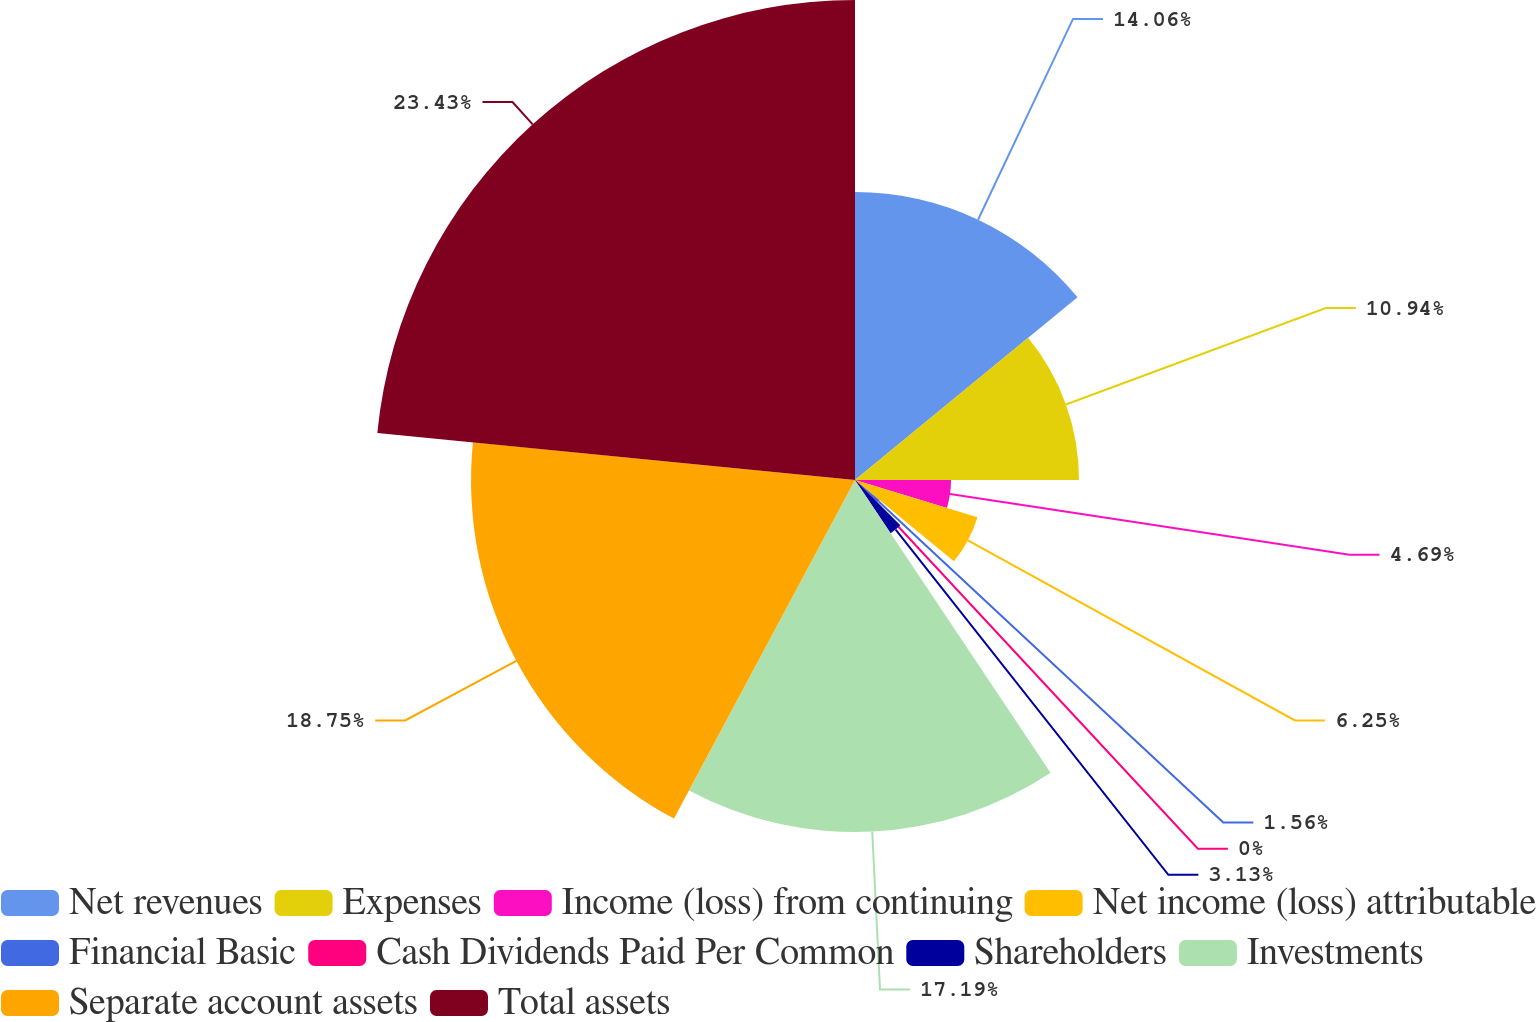Convert chart to OTSL. <chart><loc_0><loc_0><loc_500><loc_500><pie_chart><fcel>Net revenues<fcel>Expenses<fcel>Income (loss) from continuing<fcel>Net income (loss) attributable<fcel>Financial Basic<fcel>Cash Dividends Paid Per Common<fcel>Shareholders<fcel>Investments<fcel>Separate account assets<fcel>Total assets<nl><fcel>14.06%<fcel>10.94%<fcel>4.69%<fcel>6.25%<fcel>1.56%<fcel>0.0%<fcel>3.13%<fcel>17.19%<fcel>18.75%<fcel>23.44%<nl></chart> 